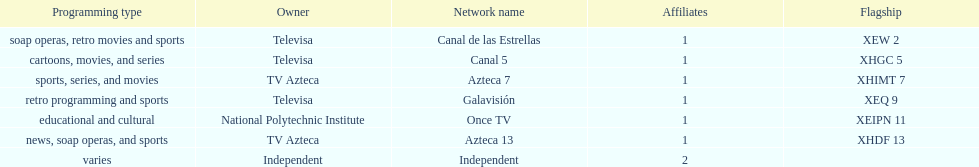Televisa owns how many networks? 3. 